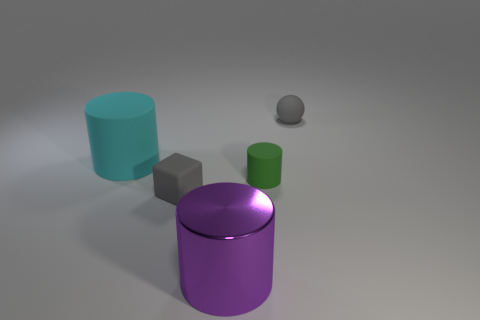Add 5 matte spheres. How many objects exist? 10 Subtract all cylinders. How many objects are left? 2 Add 3 large cylinders. How many large cylinders exist? 5 Subtract 0 blue cylinders. How many objects are left? 5 Subtract all tiny green cylinders. Subtract all small gray balls. How many objects are left? 3 Add 4 big cyan objects. How many big cyan objects are left? 5 